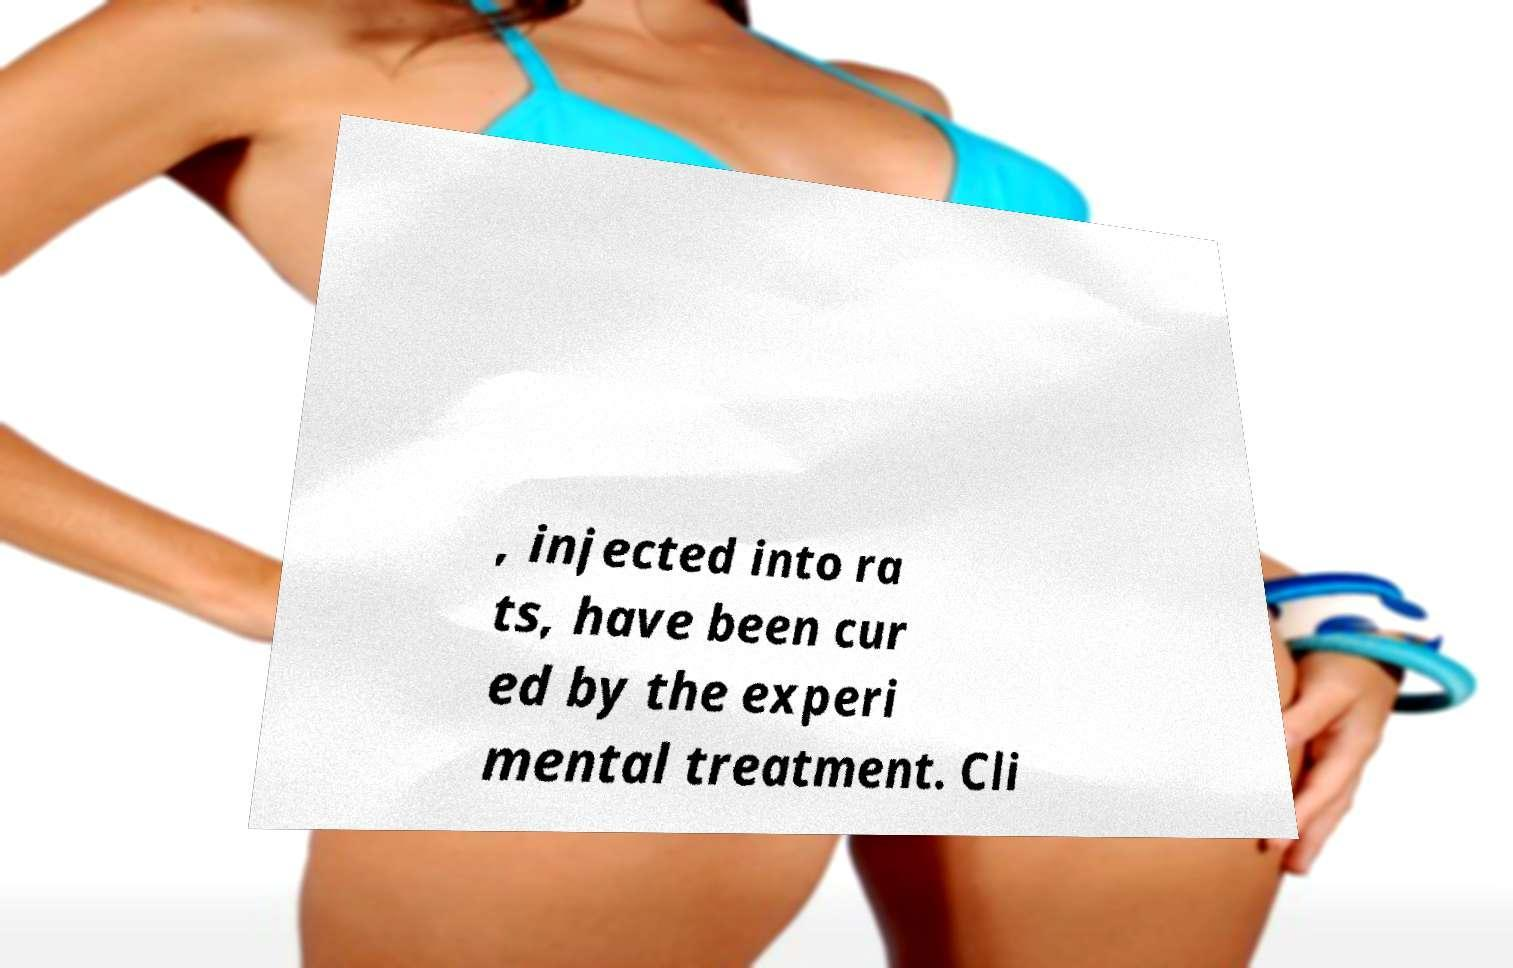I need the written content from this picture converted into text. Can you do that? , injected into ra ts, have been cur ed by the experi mental treatment. Cli 